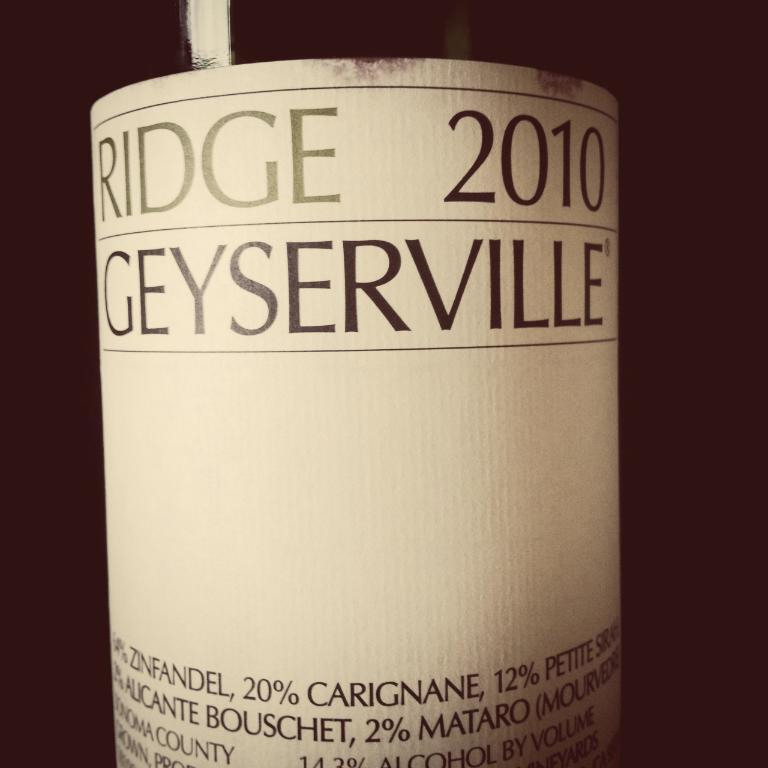Provide a one-sentence caption for the provided image. The front label of a bottle of 2010 Ridge Geyserville wine. 